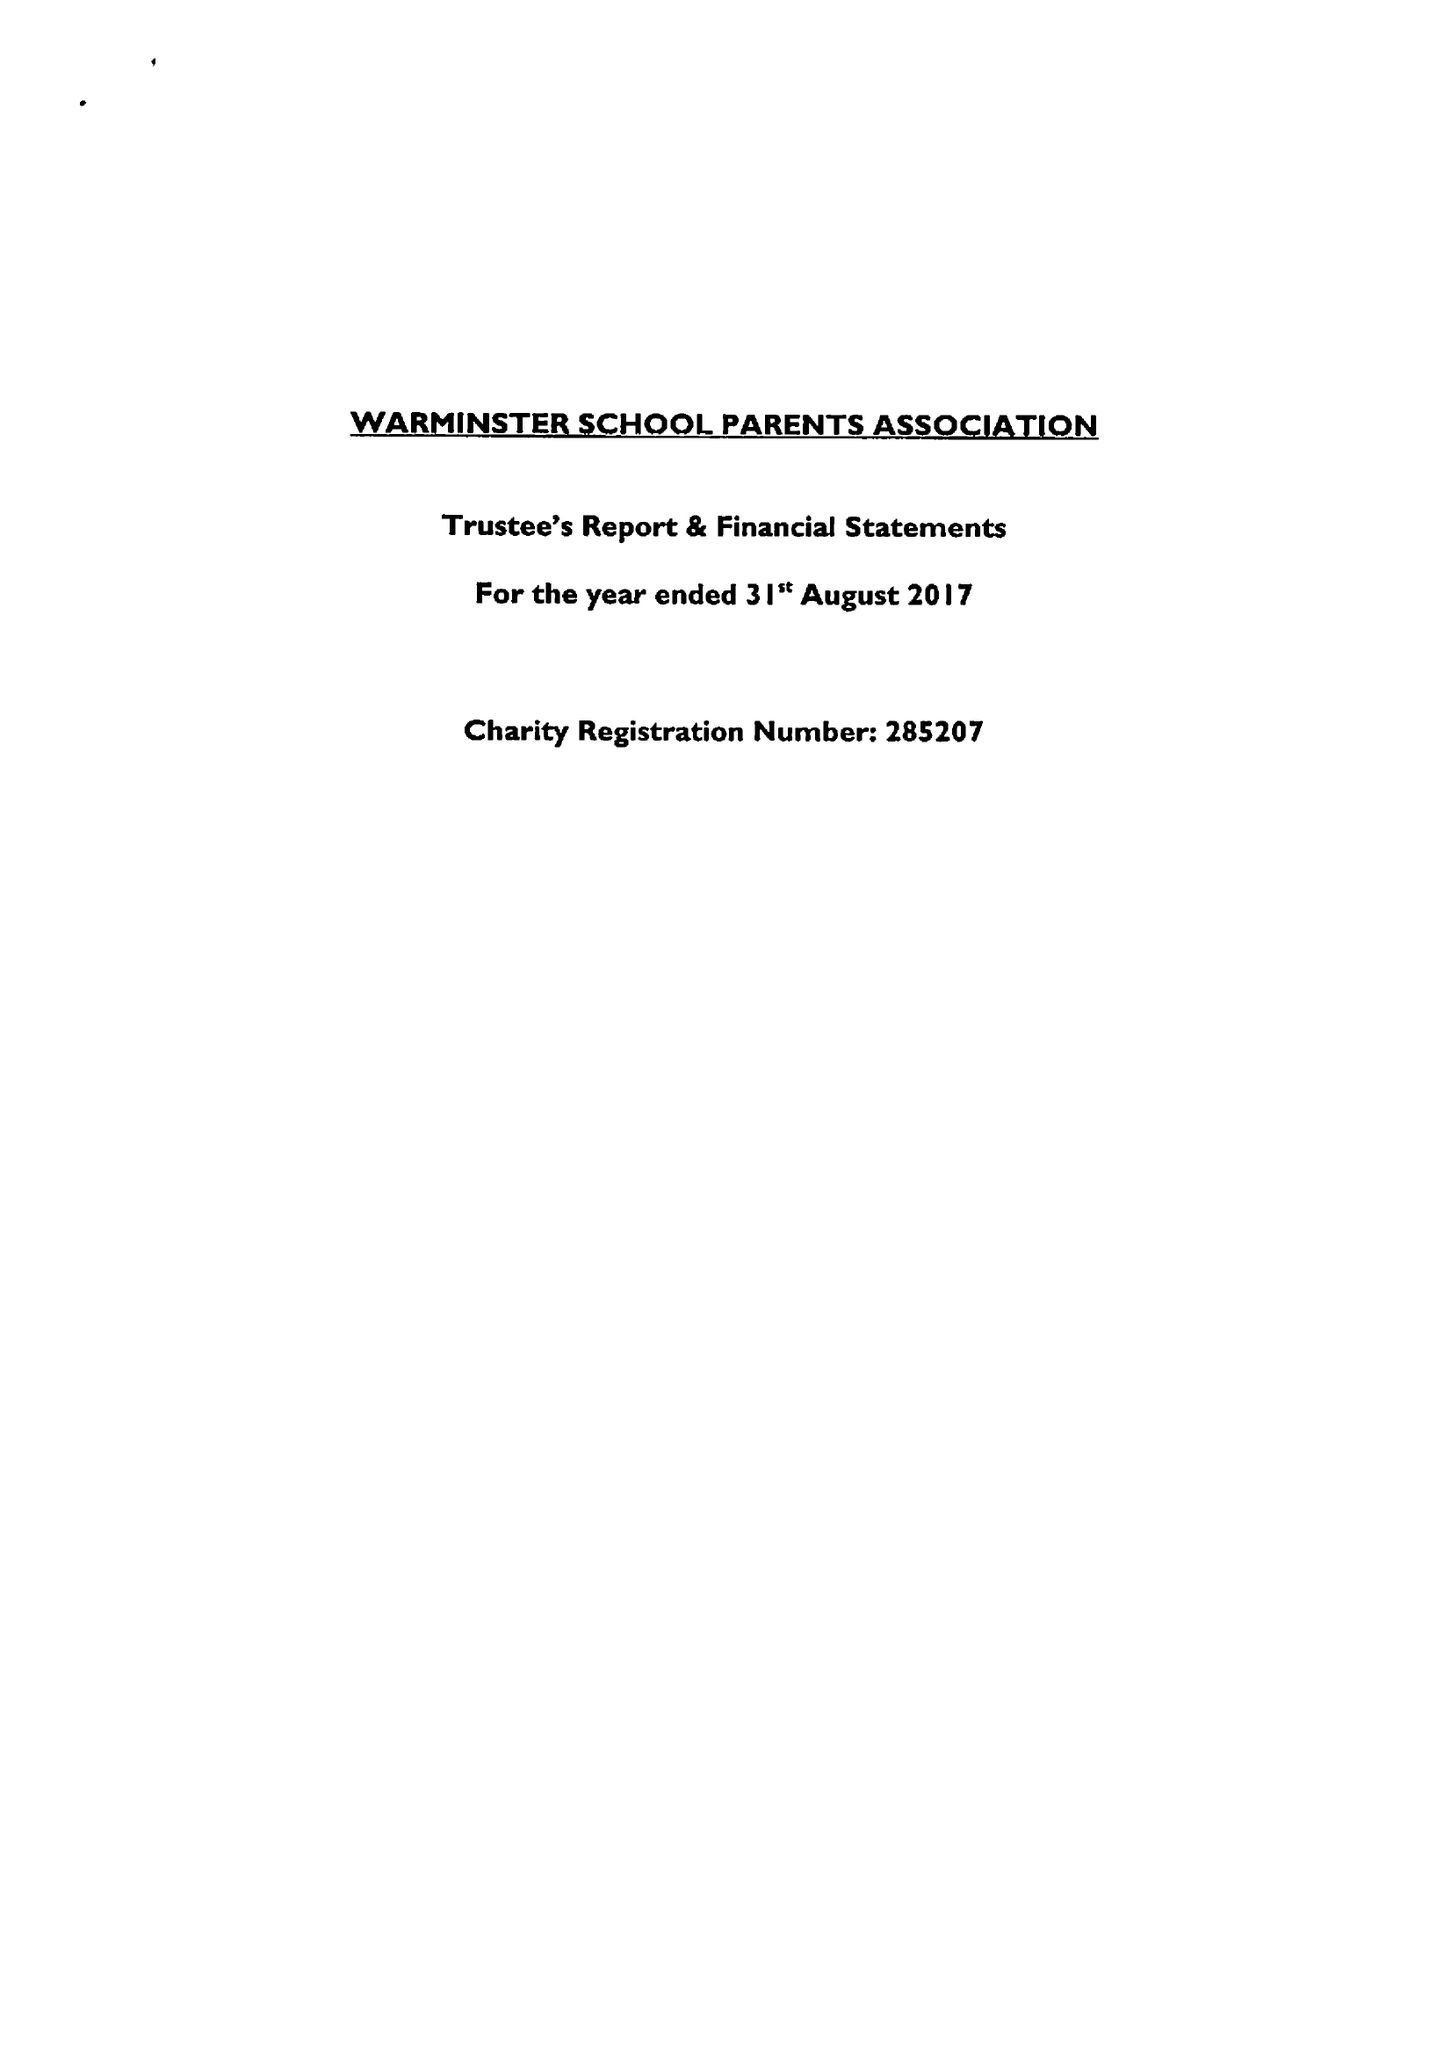What is the value for the charity_name?
Answer the question using a single word or phrase. Warminster School Parents' Association 